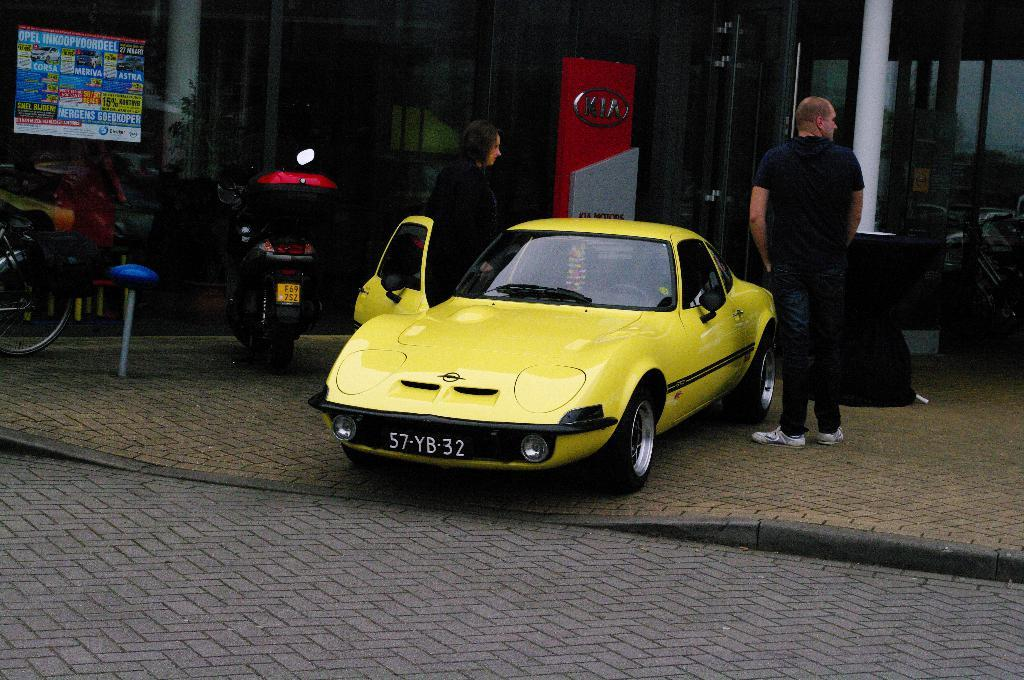<image>
Offer a succinct explanation of the picture presented. A yellow car sits in front of a Kia sign. 